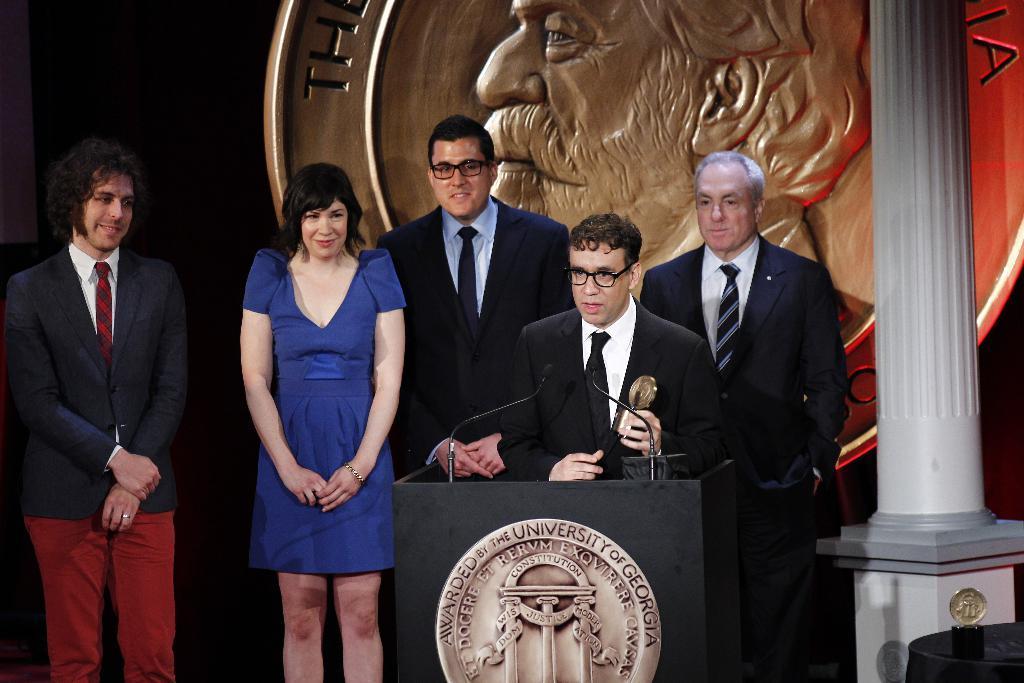Please provide a concise description of this image. In this image I can see the group of people with different color dresses. I can see the podium in-front of one person. I can see one person holding an object. To the right I can see the pillar. In the background I can see the board and there is a black background. 